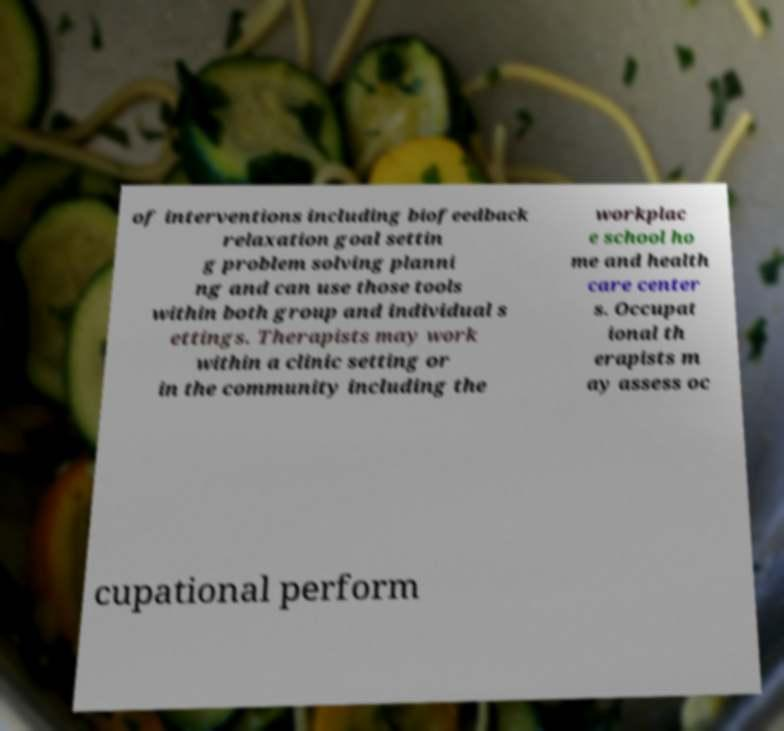Could you assist in decoding the text presented in this image and type it out clearly? of interventions including biofeedback relaxation goal settin g problem solving planni ng and can use those tools within both group and individual s ettings. Therapists may work within a clinic setting or in the community including the workplac e school ho me and health care center s. Occupat ional th erapists m ay assess oc cupational perform 